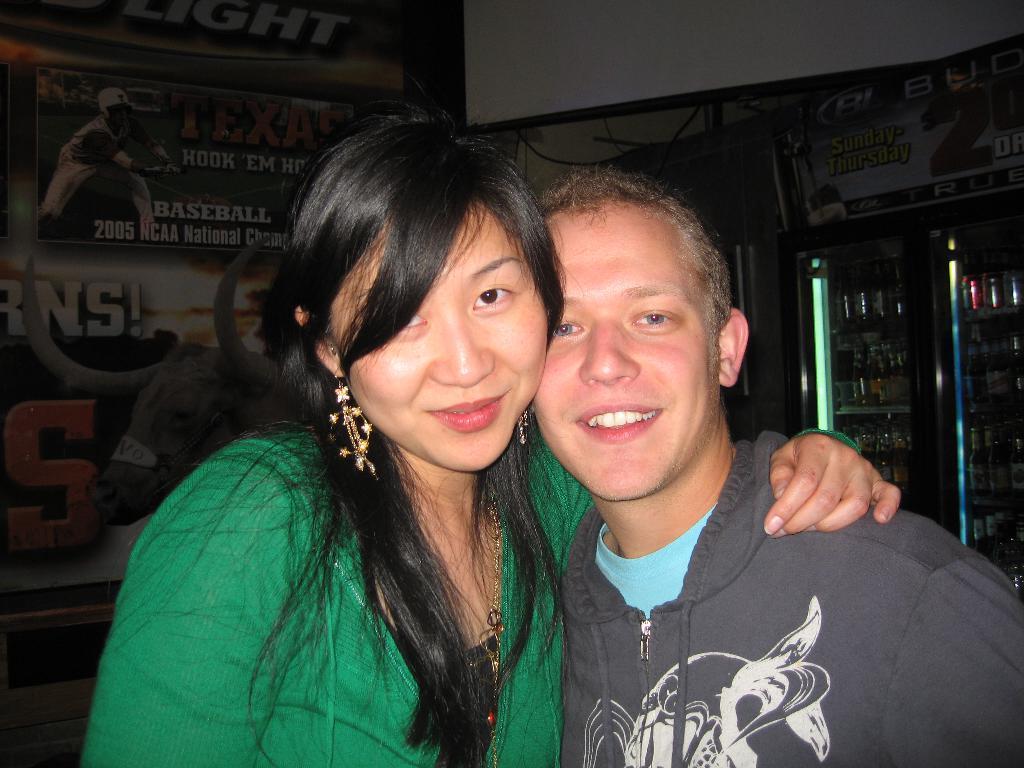Describe this image in one or two sentences. In this image I can see two people with green, grey and blue color dresses. In the background I can see the banner and there are things inside the refrigerator. 